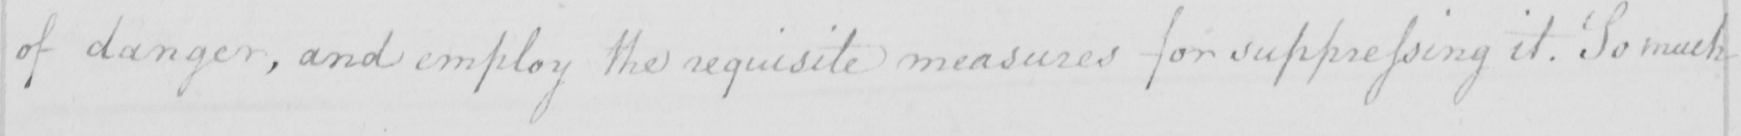Please provide the text content of this handwritten line. of danger , and employ the requisite measures for suppressing it . So much 